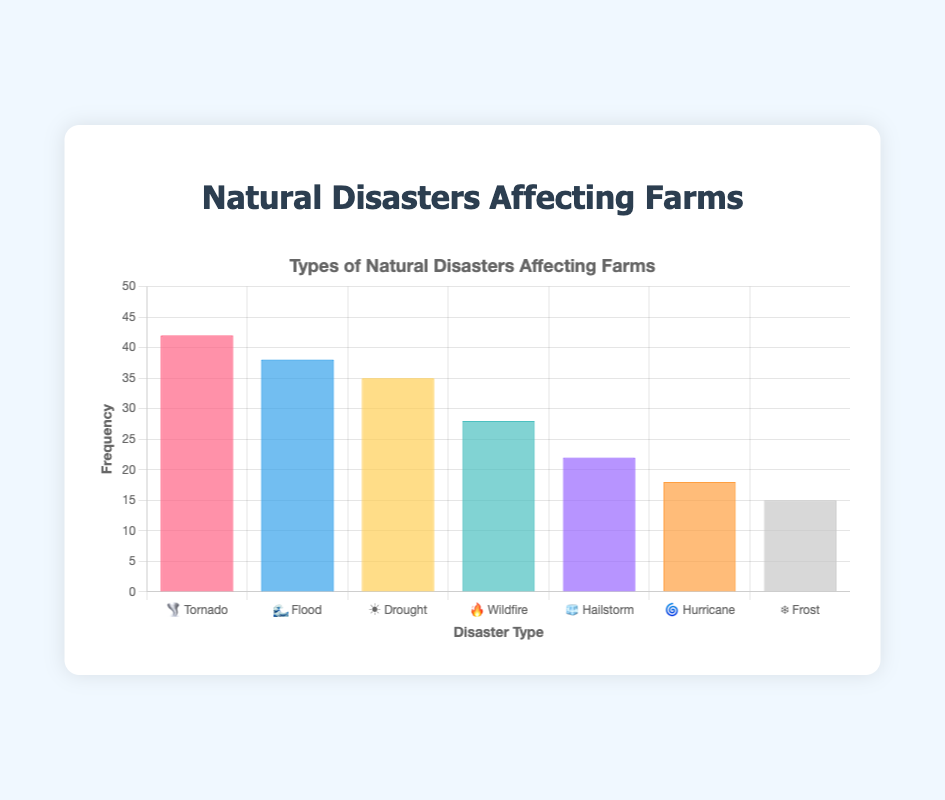Which type of natural disaster is most frequent on farms? The chart indicates various natural disasters affecting farms. The type with the highest frequency bar is the "Tornado" with a corresponding emoji 🌪️.
Answer: Tornado 🌪️ What is the combined frequency of Floods 🌊 and Wildfires 🔥? To find the combined frequency, add the frequencies of Floods (38) and Wildfires (28). 38 + 28 = 66
Answer: 66 How does the frequency of Droughts ☀️ compare to Hailstorms 🧊? The chart shows the frequency of Droughts is 35 and that of Hailstorms is 22. Since 35 is greater than 22, Droughts are more frequent than Hailstorms.
Answer: Droughts are more frequent What is the average frequency of Tornado 🌪️, Flood 🌊, and Hurricane 🌀? Add the frequencies of Tornado (42), Flood (38), and Hurricane (18), then divide by 3. (42 + 38 + 18) / 3 = 98 / 3 ≈ 32.67
Answer: 32.67 Are Frosts ❄️ the least frequent natural disaster affecting farms? From the chart, Frosts have a frequency of 15, which is lower than the frequencies of all other listed natural disasters. Thus, Frosts are the least frequent.
Answer: Yes How much more frequent are Tornadoes 🌪️ compared to Frosts ❄️? Subtract the frequency of Frosts (15) from that of Tornadoes (42). 42 - 15 = 27
Answer: 27 Which natural disasters have a frequency above 30? From the chart, Tornado (42), Flood (38), and Drought (35) all have frequencies above 30.
Answer: Tornado 🌪️, Flood 🌊, Drought ☀️ What is the frequency difference between the most and least frequent natural disasters? The most frequent is Tornado (42) and the least frequent is Frost (15). The difference is 42 - 15 = 27.
Answer: 27 If you combine the frequencies of Wildfire 🔥 and Hurricane 🌀, is the sum greater than that of Flood 🌊? Add the frequencies of Wildfire (28) and Hurricane (18) to get 46. Compare this to the frequency of Flood (38). Since 46 > 38, the combined frequency is greater.
Answer: Yes What is the median frequency of the given natural disasters? First, list all frequencies: 15, 18, 22, 28, 35, 38, 42. The median is the central number in this ordered list. So, 28 is the median value.
Answer: 28 